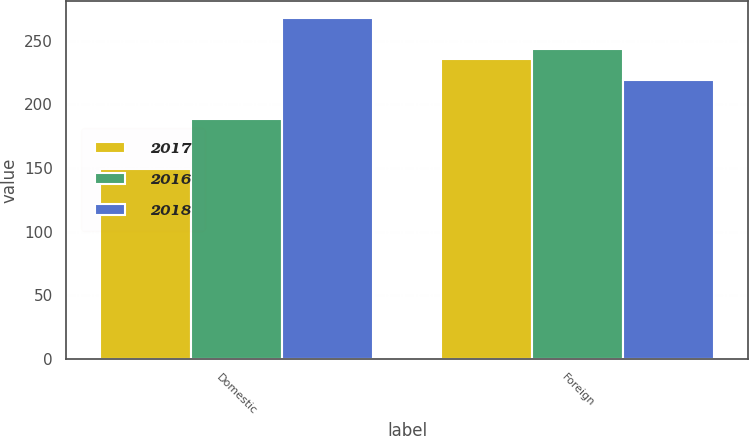Convert chart to OTSL. <chart><loc_0><loc_0><loc_500><loc_500><stacked_bar_chart><ecel><fcel>Domestic<fcel>Foreign<nl><fcel>2017<fcel>149.1<fcel>235.3<nl><fcel>2016<fcel>188.6<fcel>243.4<nl><fcel>2018<fcel>267.7<fcel>219.4<nl></chart> 